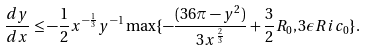<formula> <loc_0><loc_0><loc_500><loc_500>\frac { d y } { d x } \leq - \frac { 1 } { 2 } x ^ { - \frac { 1 } { 3 } } y ^ { - 1 } \max \{ - \frac { ( 3 6 \pi - y ^ { 2 } ) } { 3 x ^ { \frac { 2 } { 3 } } } + \frac { 3 } { 2 } R _ { 0 } , 3 \epsilon R i c _ { 0 } \} .</formula> 